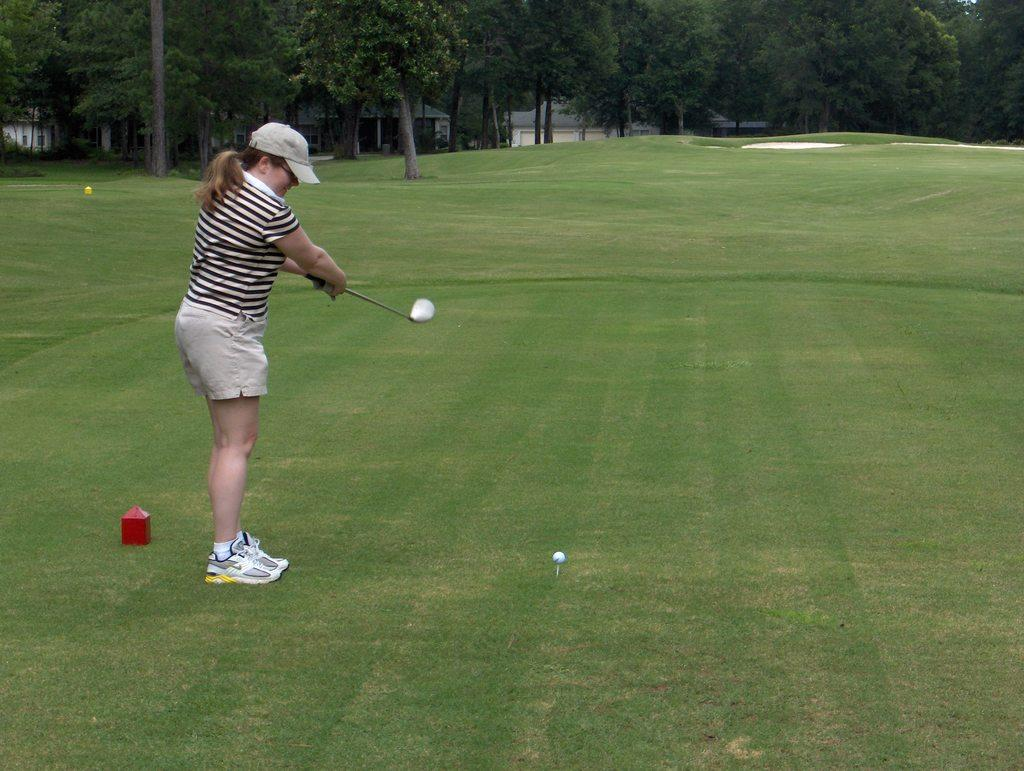Who is present in the image? There is a woman in the image. What is the woman doing in the image? The woman is standing and holding a hockey bat. What object is on the grass in the image? There is a ball on the grass in the image. What can be seen in the background of the image? There are trees in the background of the image. What type of milk is being poured into the trees in the background? There is no milk or pouring action present in the image; it features a woman holding a hockey bat and a ball on the grass, with trees in the background. 